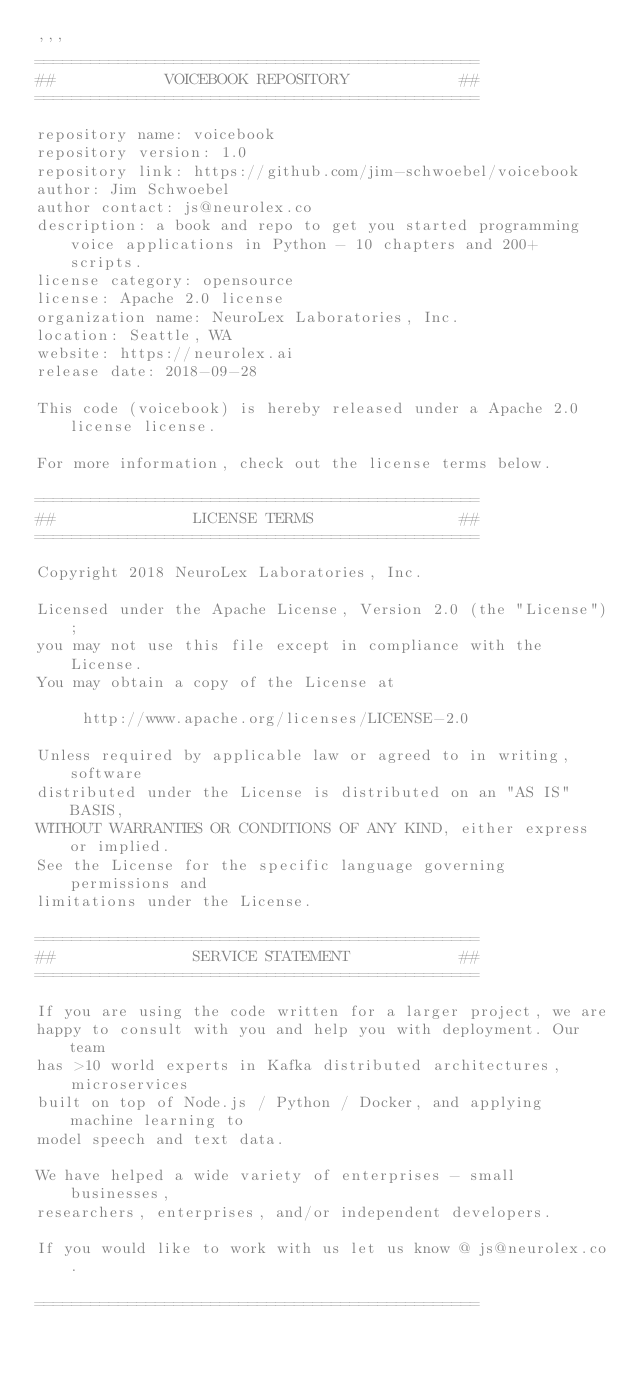Convert code to text. <code><loc_0><loc_0><loc_500><loc_500><_Python_>'''
================================================ 
##            VOICEBOOK REPOSITORY            ##      
================================================ 

repository name: voicebook 
repository version: 1.0 
repository link: https://github.com/jim-schwoebel/voicebook 
author: Jim Schwoebel 
author contact: js@neurolex.co 
description: a book and repo to get you started programming voice applications in Python - 10 chapters and 200+ scripts. 
license category: opensource 
license: Apache 2.0 license 
organization name: NeuroLex Laboratories, Inc. 
location: Seattle, WA 
website: https://neurolex.ai 
release date: 2018-09-28 

This code (voicebook) is hereby released under a Apache 2.0 license license. 

For more information, check out the license terms below. 

================================================ 
##               LICENSE TERMS                ##      
================================================ 

Copyright 2018 NeuroLex Laboratories, Inc. 

Licensed under the Apache License, Version 2.0 (the "License"); 
you may not use this file except in compliance with the License. 
You may obtain a copy of the License at 

     http://www.apache.org/licenses/LICENSE-2.0 

Unless required by applicable law or agreed to in writing, software 
distributed under the License is distributed on an "AS IS" BASIS, 
WITHOUT WARRANTIES OR CONDITIONS OF ANY KIND, either express or implied. 
See the License for the specific language governing permissions and 
limitations under the License. 

================================================ 
##               SERVICE STATEMENT            ##        
================================================ 

If you are using the code written for a larger project, we are 
happy to consult with you and help you with deployment. Our team 
has >10 world experts in Kafka distributed architectures, microservices 
built on top of Node.js / Python / Docker, and applying machine learning to 
model speech and text data. 

We have helped a wide variety of enterprises - small businesses, 
researchers, enterprises, and/or independent developers. 

If you would like to work with us let us know @ js@neurolex.co. 

================================================ </code> 